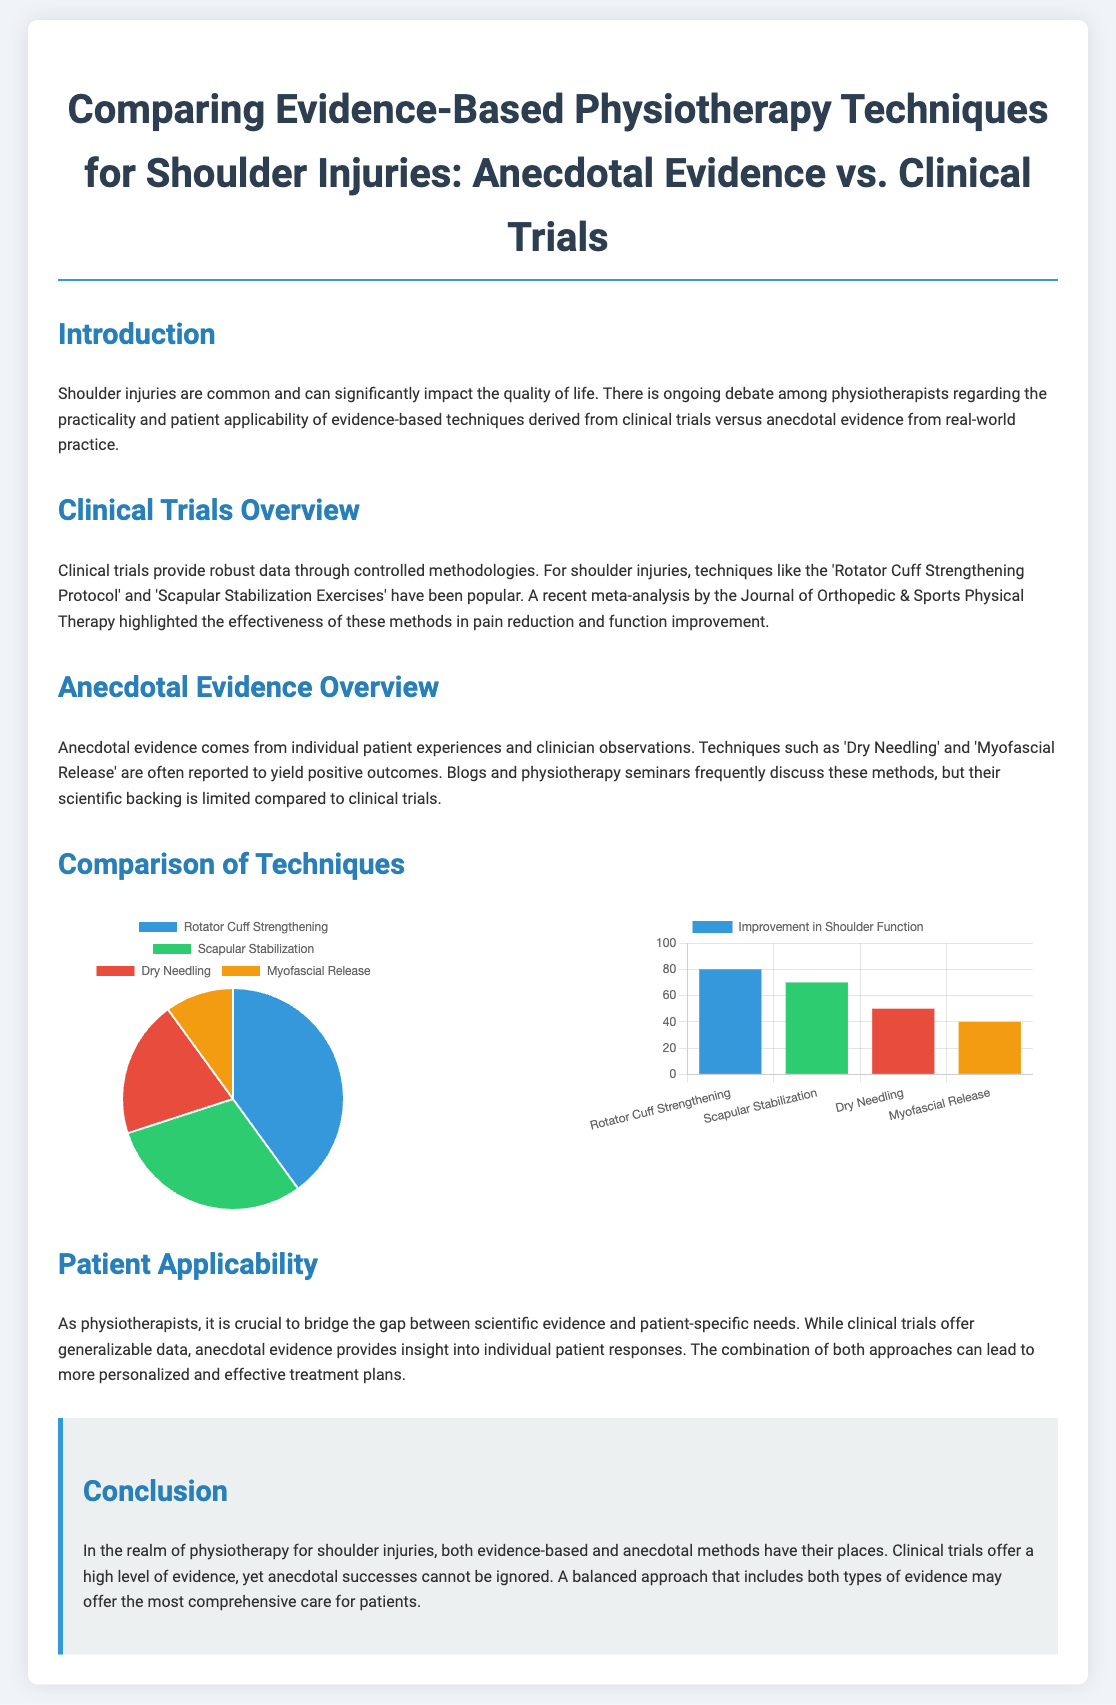What is the primary focus of the document? The primary focus is on comparing evidence-based physiotherapy techniques for shoulder injuries, specifically anecdotal evidence vs. clinical trials.
Answer: Comparing evidence-based physiotherapy techniques What are the four techniques mentioned in the pie chart? The techniques are Rotator Cuff Strengthening, Scapular Stabilization, Dry Needling, and Myofascial Release as shown in the pie chart.
Answer: Rotator Cuff Strengthening, Scapular Stabilization, Dry Needling, Myofascial Release What percentage of the pie chart represents Dry Needling? The pie chart indicates that Dry Needling accounts for 20% of the effectiveness in pain reduction.
Answer: 20% Which technique has the highest percentage in pain reduction according to the pie chart? The pie chart shows that Rotator Cuff Strengthening has the highest percentage in pain reduction.
Answer: Rotator Cuff Strengthening What is the maximum score on the bar chart for Improvement in Shoulder Function? The bar chart indicates that the maximum score for any technique in Improvement in Shoulder Function is 80.
Answer: 80 Which method has a score of 50 for Improvement in Shoulder Function? The bar chart shows that Dry Needling has a score of 50 for Improvement in Shoulder Function.
Answer: Dry Needling What color is used to represent Myofascial Release in both charts? The color used for Myofascial Release in both the pie and bar charts is orange, represented by the hex code f39c12.
Answer: Orange What conclusion is drawn about combining evidence types in treatment plans? The document concludes that a balanced approach that includes both evidence types may offer the most comprehensive care for patients.
Answer: Balanced approach for comprehensive care 